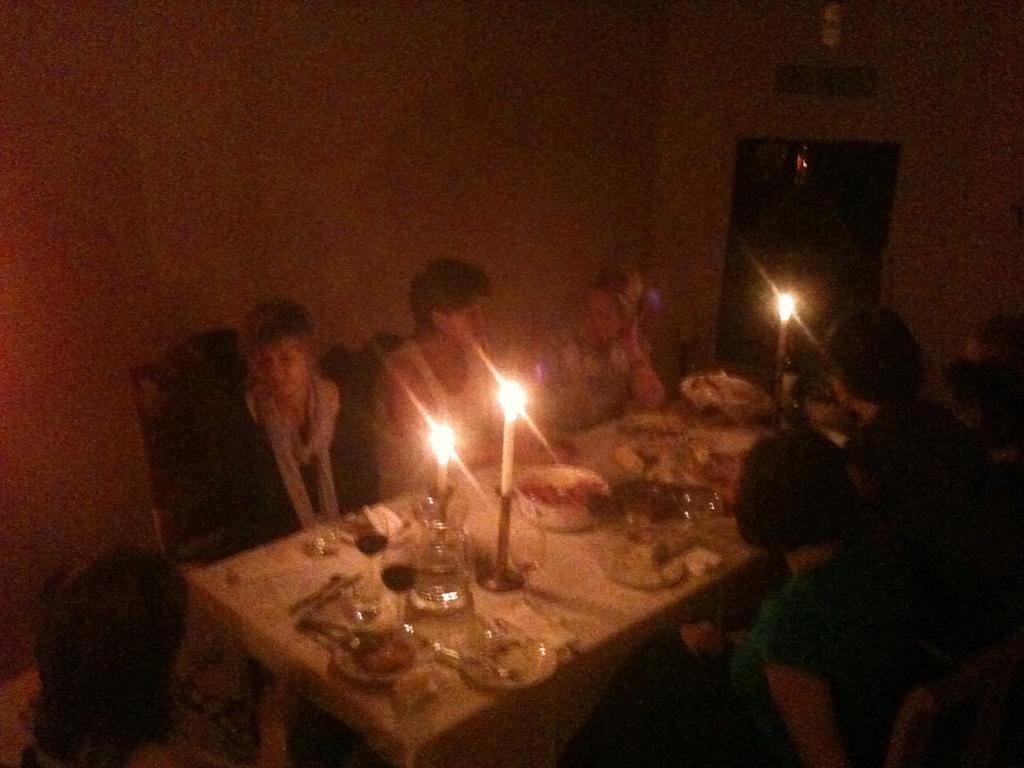Describe this image in one or two sentences. In this picture I can see candles, plates, spoons on the dining table. I can see people sitting on the chair. I can see the wall. 